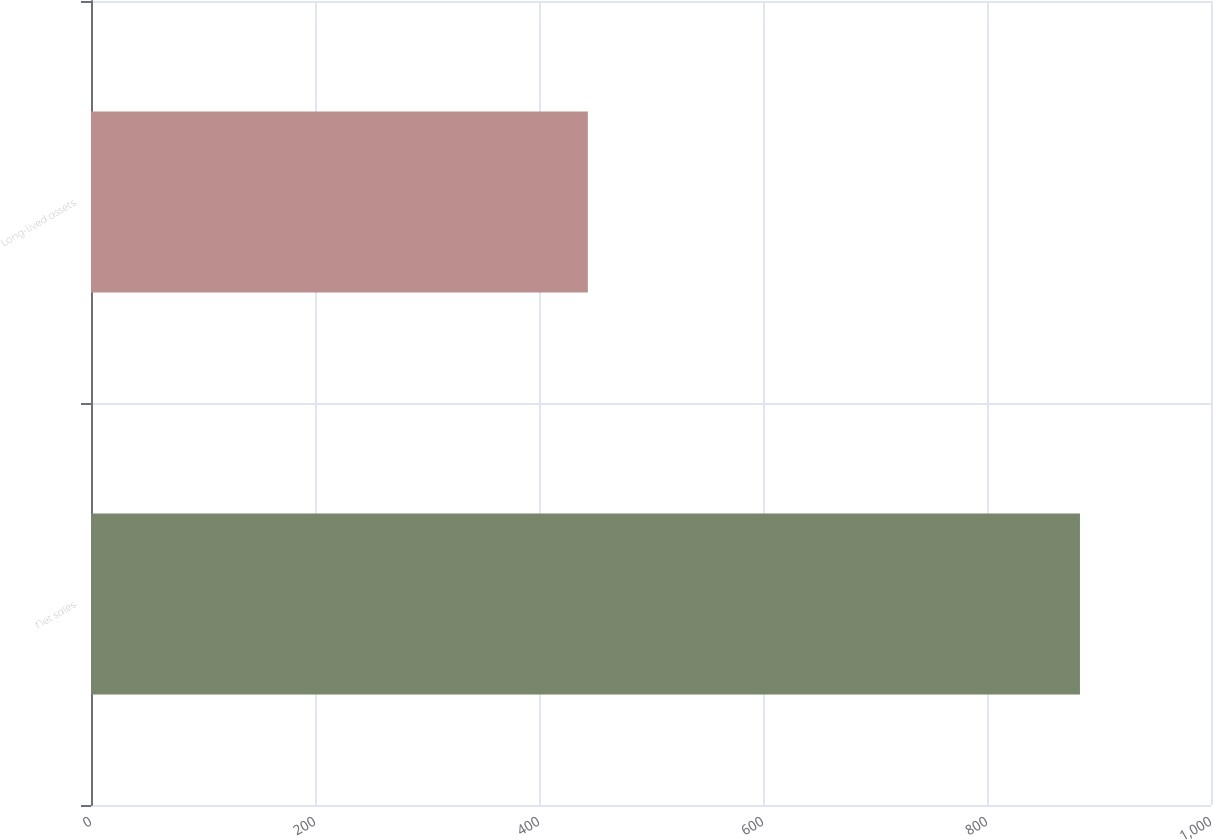Convert chart to OTSL. <chart><loc_0><loc_0><loc_500><loc_500><bar_chart><fcel>Net sales<fcel>Long-lived assets<nl><fcel>883<fcel>443.6<nl></chart> 